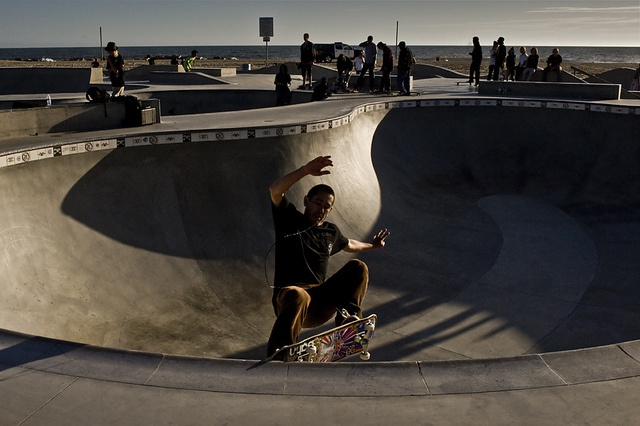Describe the objects in this image and their specific colors. I can see people in gray, black, and maroon tones, skateboard in gray, black, olive, and maroon tones, people in gray, black, and darkgray tones, people in gray, black, and tan tones, and people in gray, black, and darkgray tones in this image. 